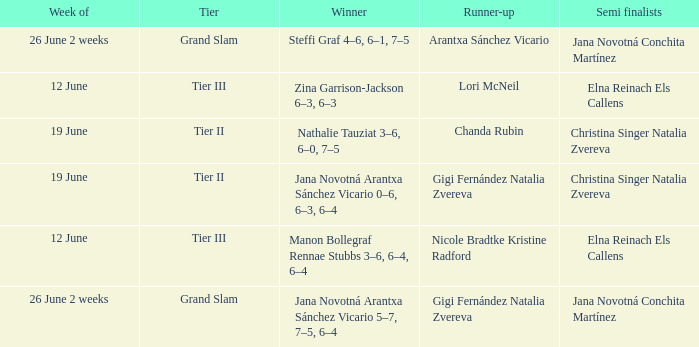Who is the winner in the week listed as 26 June 2 weeks, when the runner-up is Arantxa Sánchez Vicario? Steffi Graf 4–6, 6–1, 7–5. 